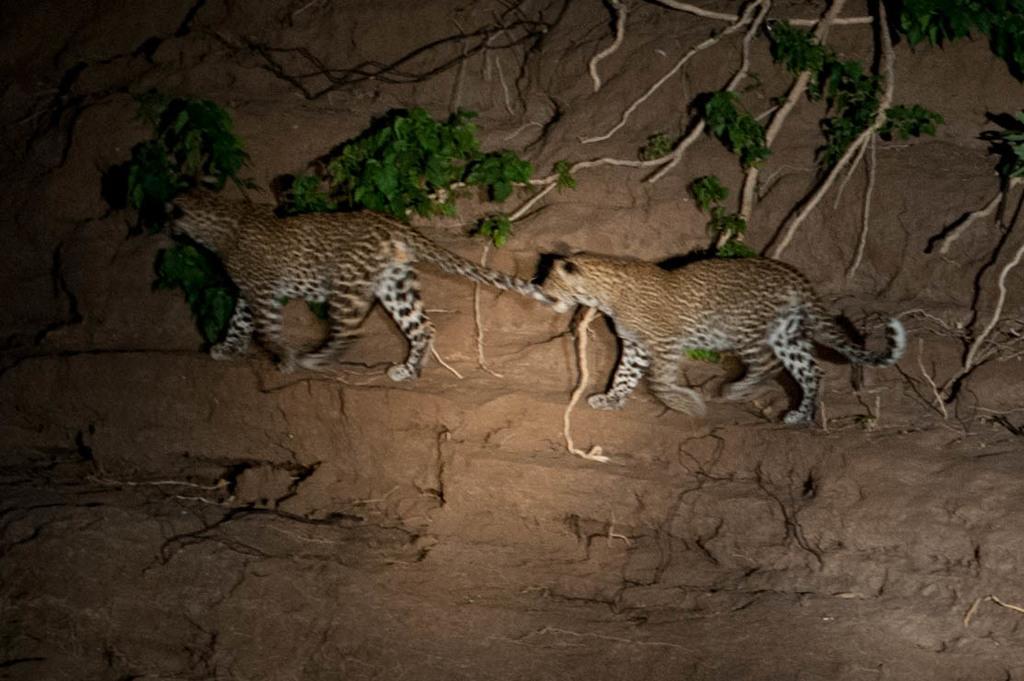Please provide a concise description of this image. On the left side, there is a leopard walking on the wall. Behind this leopard, there is another leopard walking on the wall. In the background, there are plants and roots of the trees. 